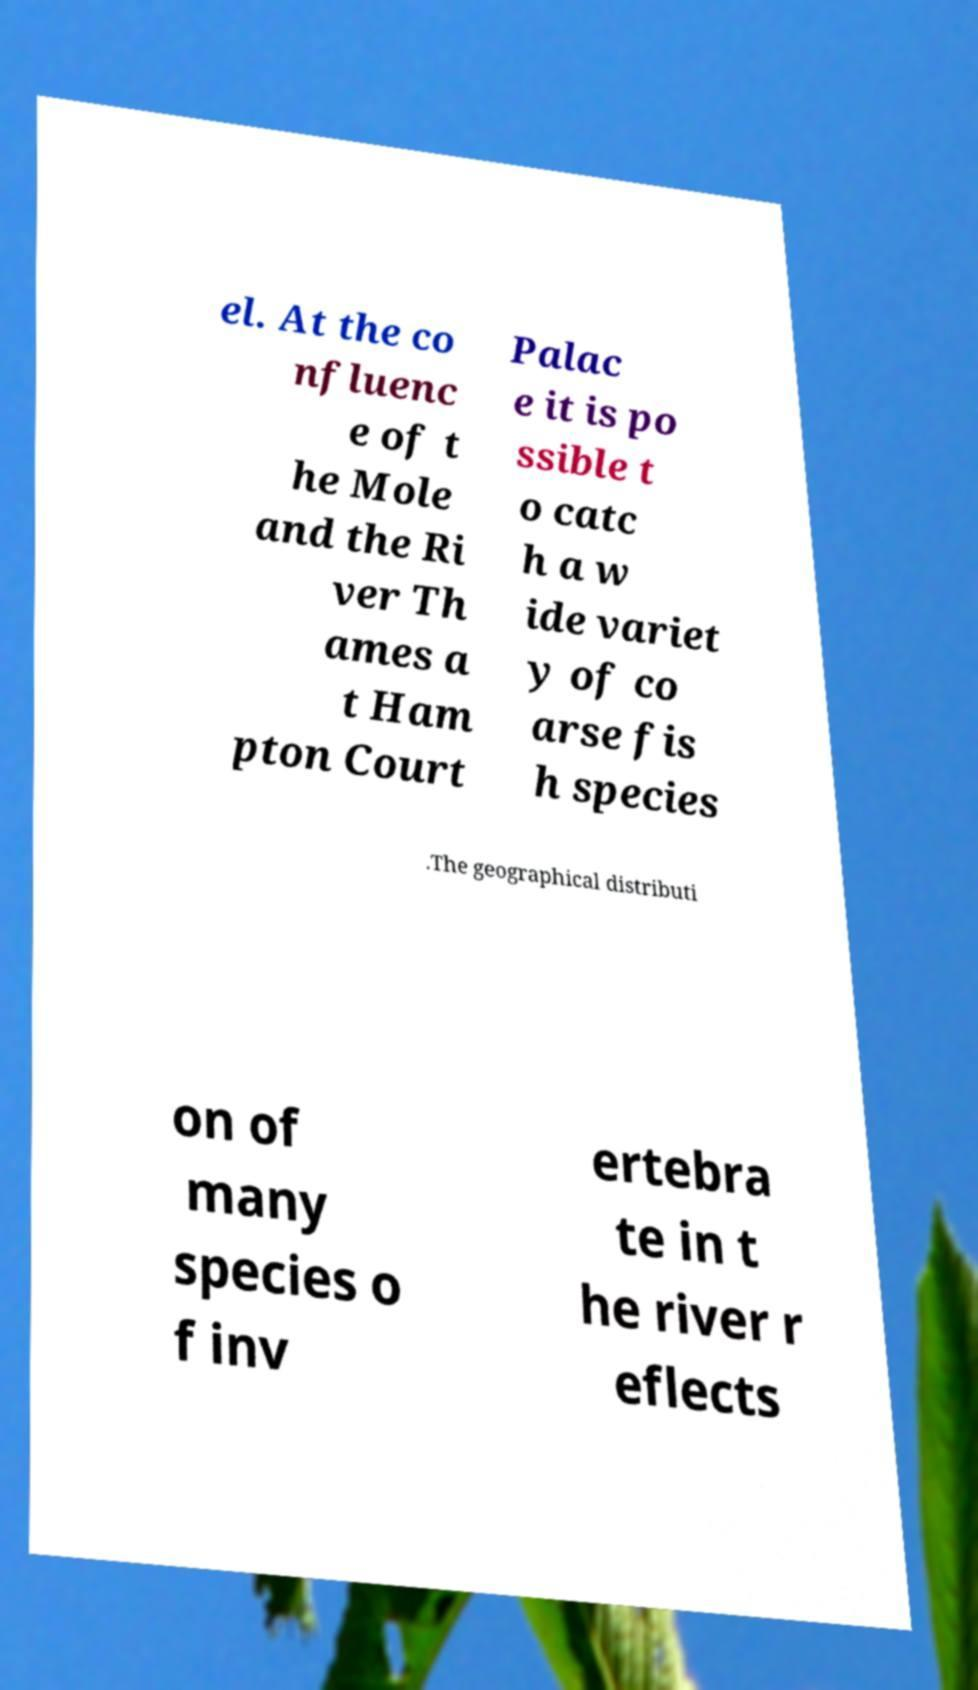Can you read and provide the text displayed in the image?This photo seems to have some interesting text. Can you extract and type it out for me? el. At the co nfluenc e of t he Mole and the Ri ver Th ames a t Ham pton Court Palac e it is po ssible t o catc h a w ide variet y of co arse fis h species .The geographical distributi on of many species o f inv ertebra te in t he river r eflects 